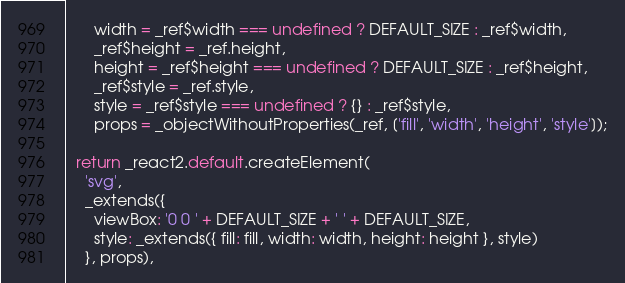<code> <loc_0><loc_0><loc_500><loc_500><_JavaScript_>      width = _ref$width === undefined ? DEFAULT_SIZE : _ref$width,
      _ref$height = _ref.height,
      height = _ref$height === undefined ? DEFAULT_SIZE : _ref$height,
      _ref$style = _ref.style,
      style = _ref$style === undefined ? {} : _ref$style,
      props = _objectWithoutProperties(_ref, ['fill', 'width', 'height', 'style']);

  return _react2.default.createElement(
    'svg',
    _extends({
      viewBox: '0 0 ' + DEFAULT_SIZE + ' ' + DEFAULT_SIZE,
      style: _extends({ fill: fill, width: width, height: height }, style)
    }, props),</code> 